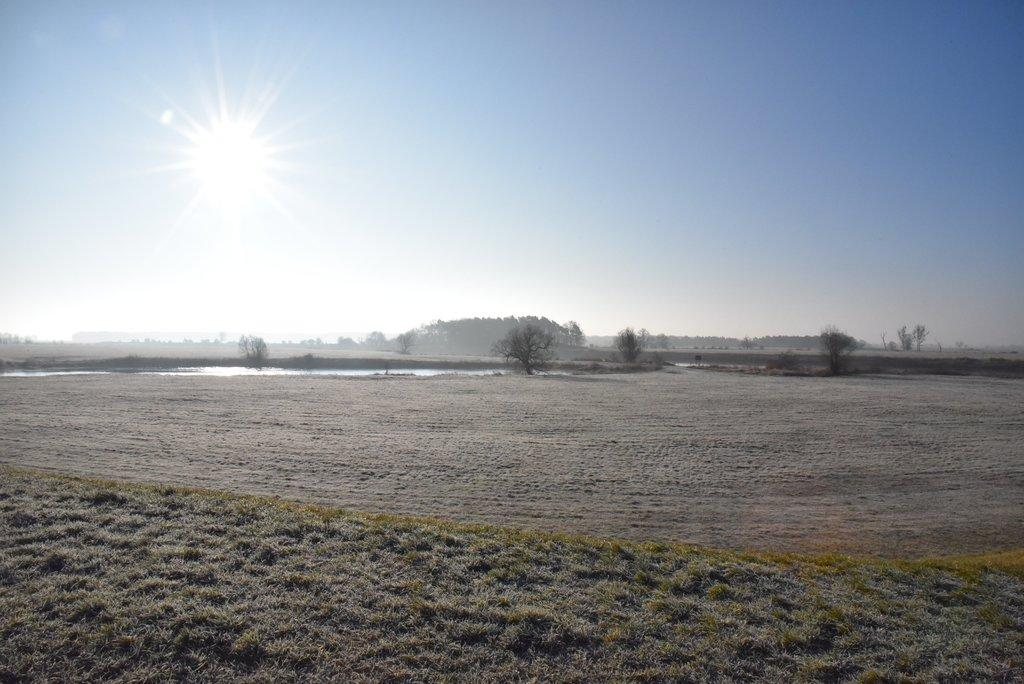What type of vegetation can be seen in the image? There are trees in the image. What is located in the center of the image? There is water in the center of the image. What celestial body is visible in the image? The sun is visible in the image. Can you see any sheep grazing near the water in the image? There are no sheep present in the image; it features trees, water, and the sun. Is there a club visible in the image? There is no club present in the image. 